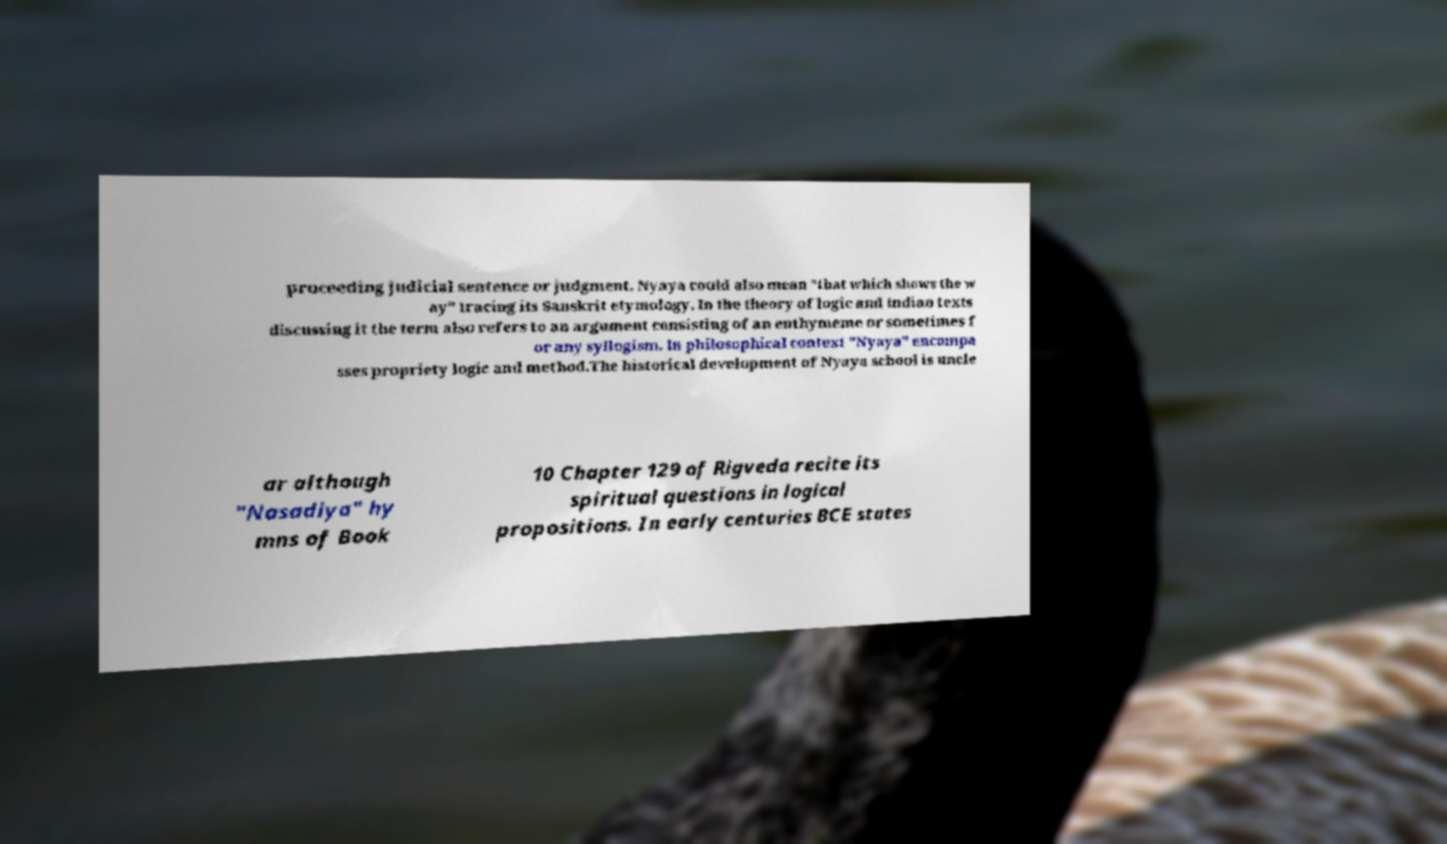For documentation purposes, I need the text within this image transcribed. Could you provide that? proceeding judicial sentence or judgment. Nyaya could also mean "that which shows the w ay" tracing its Sanskrit etymology. In the theory of logic and Indian texts discussing it the term also refers to an argument consisting of an enthymeme or sometimes f or any syllogism. In philosophical context "Nyaya" encompa sses propriety logic and method.The historical development of Nyaya school is uncle ar although "Nasadiya" hy mns of Book 10 Chapter 129 of Rigveda recite its spiritual questions in logical propositions. In early centuries BCE states 